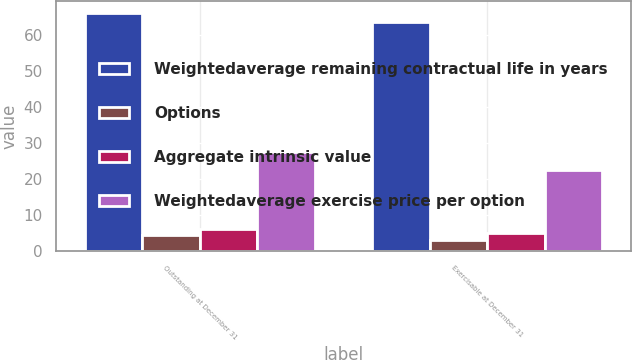Convert chart to OTSL. <chart><loc_0><loc_0><loc_500><loc_500><stacked_bar_chart><ecel><fcel>Outstanding at December 31<fcel>Exercisable at December 31<nl><fcel>Weightedaverage remaining contractual life in years<fcel>65.96<fcel>63.39<nl><fcel>Options<fcel>4.6<fcel>3.2<nl><fcel>Aggregate intrinsic value<fcel>6.2<fcel>5.2<nl><fcel>Weightedaverage exercise price per option<fcel>27.4<fcel>22.4<nl></chart> 